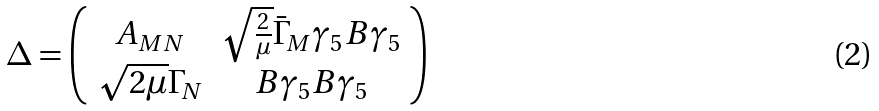<formula> <loc_0><loc_0><loc_500><loc_500>\Delta = \left ( \begin{array} { c c } A _ { M N } & \sqrt { \frac { 2 } { \mu } } \bar { \Gamma } _ { M } \gamma _ { 5 } B \gamma _ { 5 } \\ \sqrt { 2 \mu } \Gamma _ { N } & B \gamma _ { 5 } B \gamma _ { 5 } \end{array} \right )</formula> 